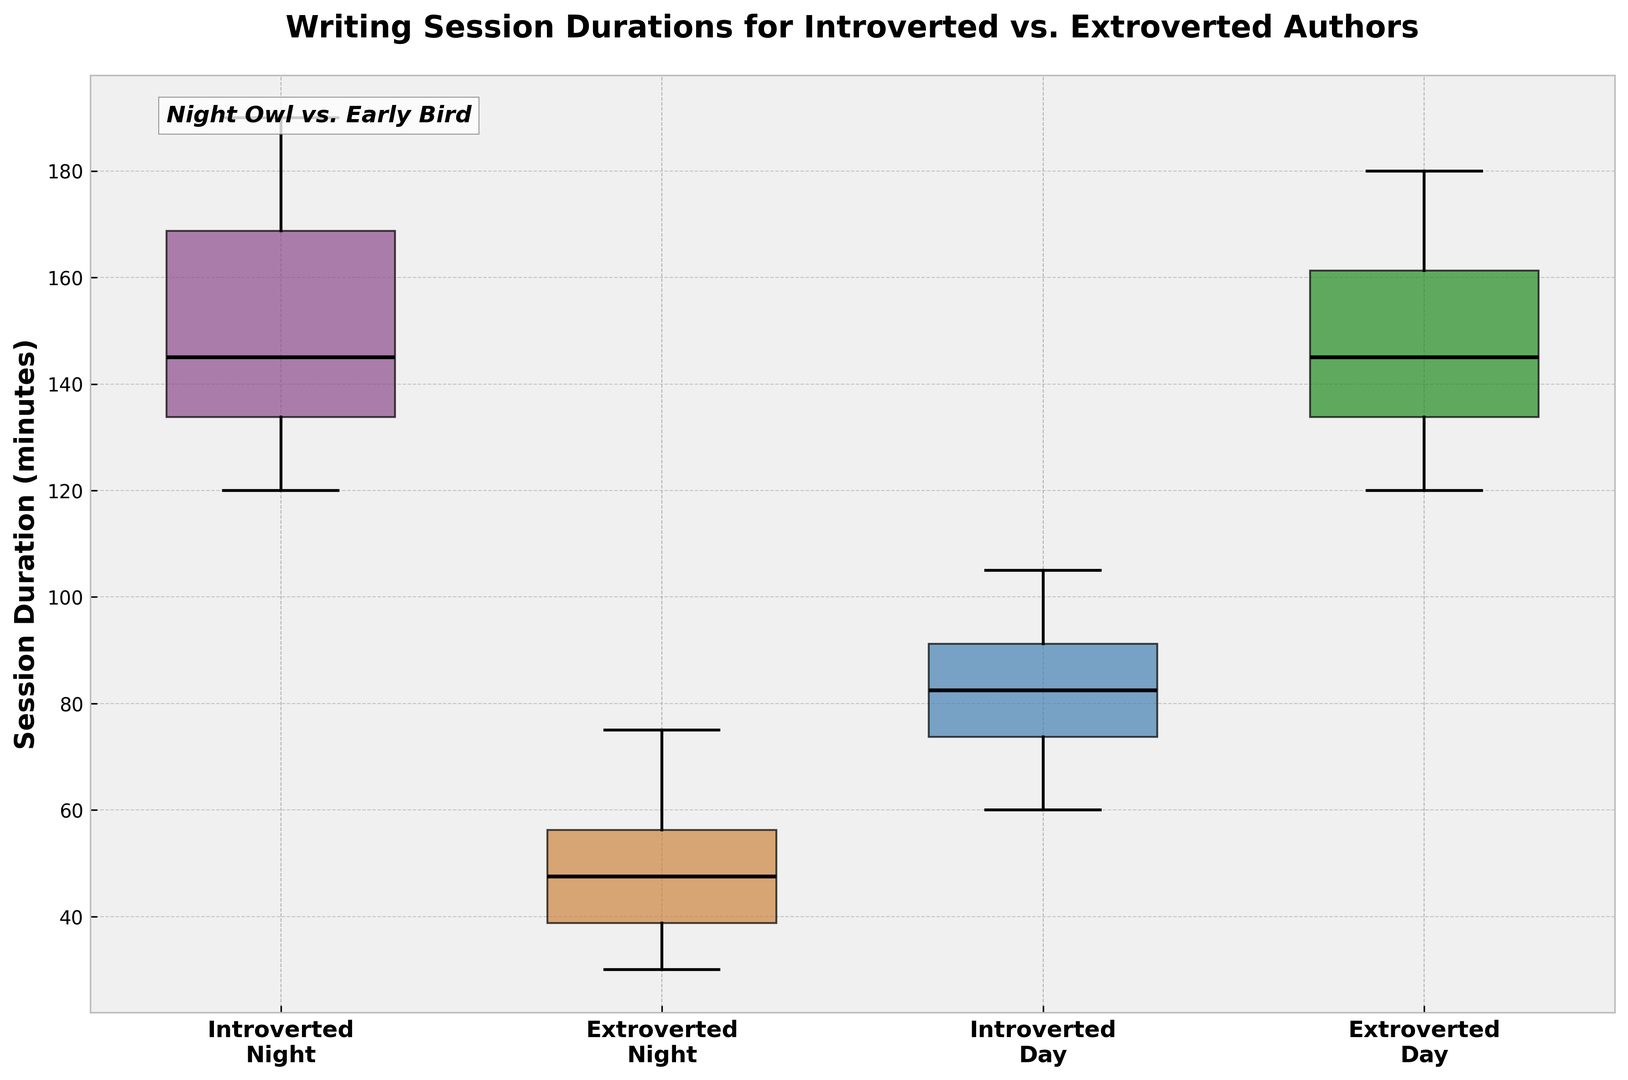What is the median duration for introverted authors at night? The box plot for introverted authors at night shows a line inside the box, which represents the median. By looking directly at the plot, we see the line is at 140 minutes.
Answer: 140 minutes Which group has the highest median session duration? By comparing the medians represented by the lines inside the boxes, the group "Extroverted Day" has the highest median as its line is at 140 minutes, which is higher than all other groups.
Answer: Extroverted Day Are introverted authors' sessions longer at night or during the day? Comparing the median values for introverted authors: at night, the median is 140 minutes, and during the day, it is 85 minutes. Since 140 > 85, introverted authors have longer sessions at night.
Answer: Night Which group has the smallest range of session durations? The range can be observed by looking at the length of the whiskers from the smallest to the largest value. "Extroverted Night" has the smallest range as its whiskers appear shorter compared to the other groups.
Answer: Extroverted Night What is the interquartile range (IQR) for extroverted authors during the day? The IQR is the length of the box, which represents the middle 50% of the data. For extroverted authors during the day, the box stretches from approximately 140 minutes (Q1) to 165 minutes (Q3), making the IQR 165 - 140 = 25 minutes.
Answer: 25 minutes How do the durations for extroverted authors at night compare to those of introverted authors at night? By comparing the boxes, introverted authors at night have a higher median and a wider range of durations compared to extroverted authors at night. This indicates that introverted authors tend to have longer and more varied session durations at night.
Answer: Introverted Night has longer and more varied In which time of day do introverted authors show more variability in their writing sessions? Variability is indicated by the length of the whiskers and the box. For introverted authors, the box and whiskers during the night are longer than during the day, showing more variability at night.
Answer: Night What is the most consistent writing session duration pattern observed in the plot? "Extroverted Night" shows the most consistent pattern, as it has the smallest range of values and the shortest whiskers, indicating less variability.
Answer: Extroverted Night Is there a group whose median session duration is equal to another group's lower quartile? The median session duration for "Introverted Night" is 140 minutes, which is also the lower quartile (Q1) of "Extroverted Day". This indicates that 50% of extroverted authors during the day have session durations less than or equal to the median duration of introverted authors at night.
Answer: Yes, Introverted Night median = Extroverted Day Q1 Which group shows an overlap in their interquartile range (IQR) with the introverted authors during the day? The IQR for introverted authors during the day is between 70 and 95 minutes. The IQR for "Extroverted Night" appears to somewhat overlap with these values, indicating that their session durations partially coincide.
Answer: Extroverted Night 